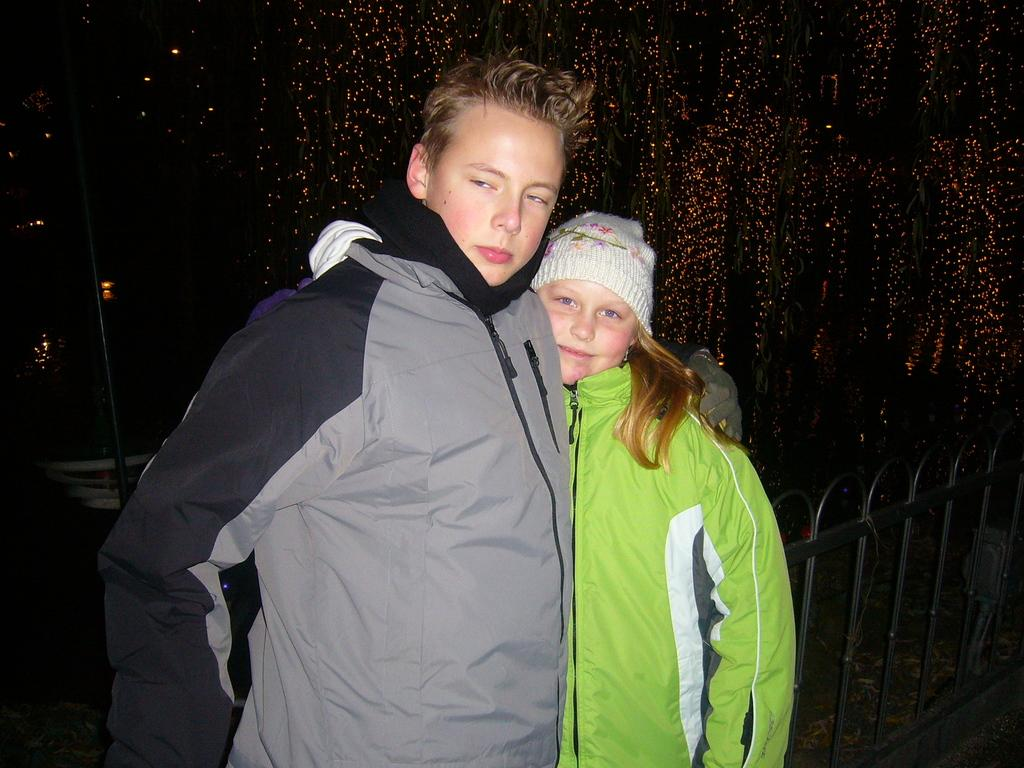How many people are in the image? There are two persons in the center of the image. What are the persons wearing? The persons are wearing jackets. What are the persons doing in the image? The persons are standing. What can be seen in the background of the image? There are lights, a pole, a metal fence, and other objects visible in the background of the image. What type of meal is being prepared by the persons in the image? There is no meal preparation visible in the image; the persons are simply standing. Can you tell me what type of drum is being played by the persons in the image? There is no drum present in the image; the persons are wearing jackets and standing. 